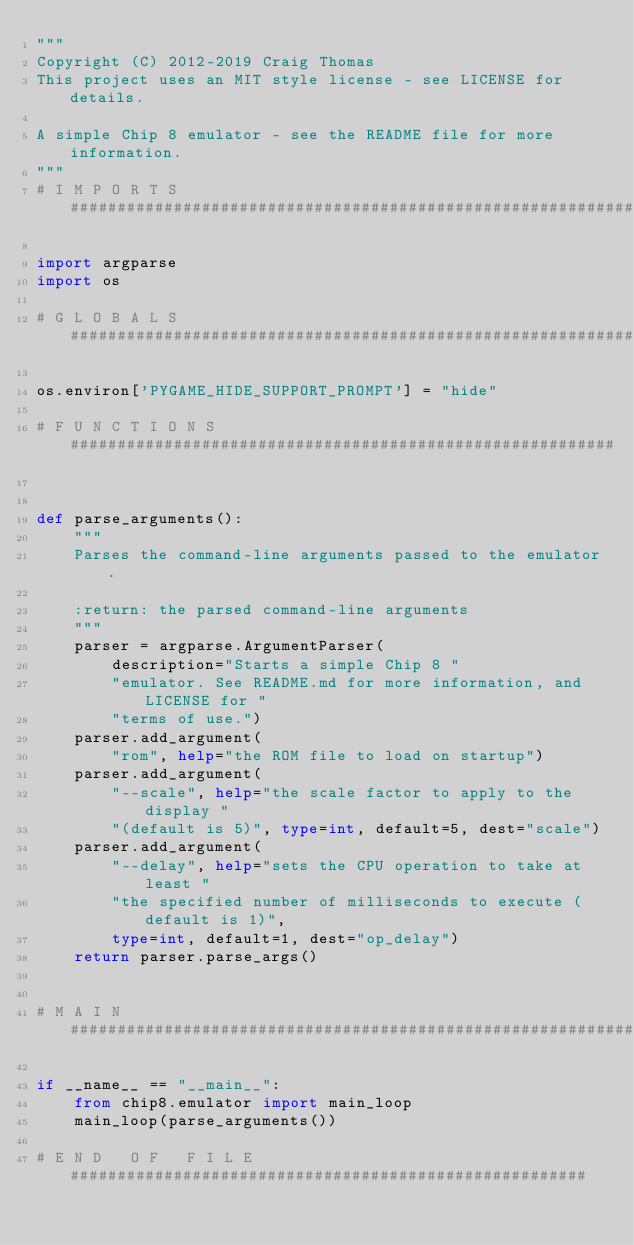<code> <loc_0><loc_0><loc_500><loc_500><_Python_>"""
Copyright (C) 2012-2019 Craig Thomas
This project uses an MIT style license - see LICENSE for details.

A simple Chip 8 emulator - see the README file for more information.
"""
# I M P O R T S ###############################################################

import argparse
import os

# G L O B A L S ###############################################################

os.environ['PYGAME_HIDE_SUPPORT_PROMPT'] = "hide"

# F U N C T I O N S  ##########################################################


def parse_arguments():
    """
    Parses the command-line arguments passed to the emulator.

    :return: the parsed command-line arguments
    """
    parser = argparse.ArgumentParser(
        description="Starts a simple Chip 8 "
        "emulator. See README.md for more information, and LICENSE for "
        "terms of use.")
    parser.add_argument(
        "rom", help="the ROM file to load on startup")
    parser.add_argument(
        "--scale", help="the scale factor to apply to the display "
        "(default is 5)", type=int, default=5, dest="scale")
    parser.add_argument(
        "--delay", help="sets the CPU operation to take at least "
        "the specified number of milliseconds to execute (default is 1)",
        type=int, default=1, dest="op_delay")
    return parser.parse_args()


# M A I N #####################################################################

if __name__ == "__main__":
    from chip8.emulator import main_loop
    main_loop(parse_arguments())

# E N D   O F   F I L E #######################################################
</code> 